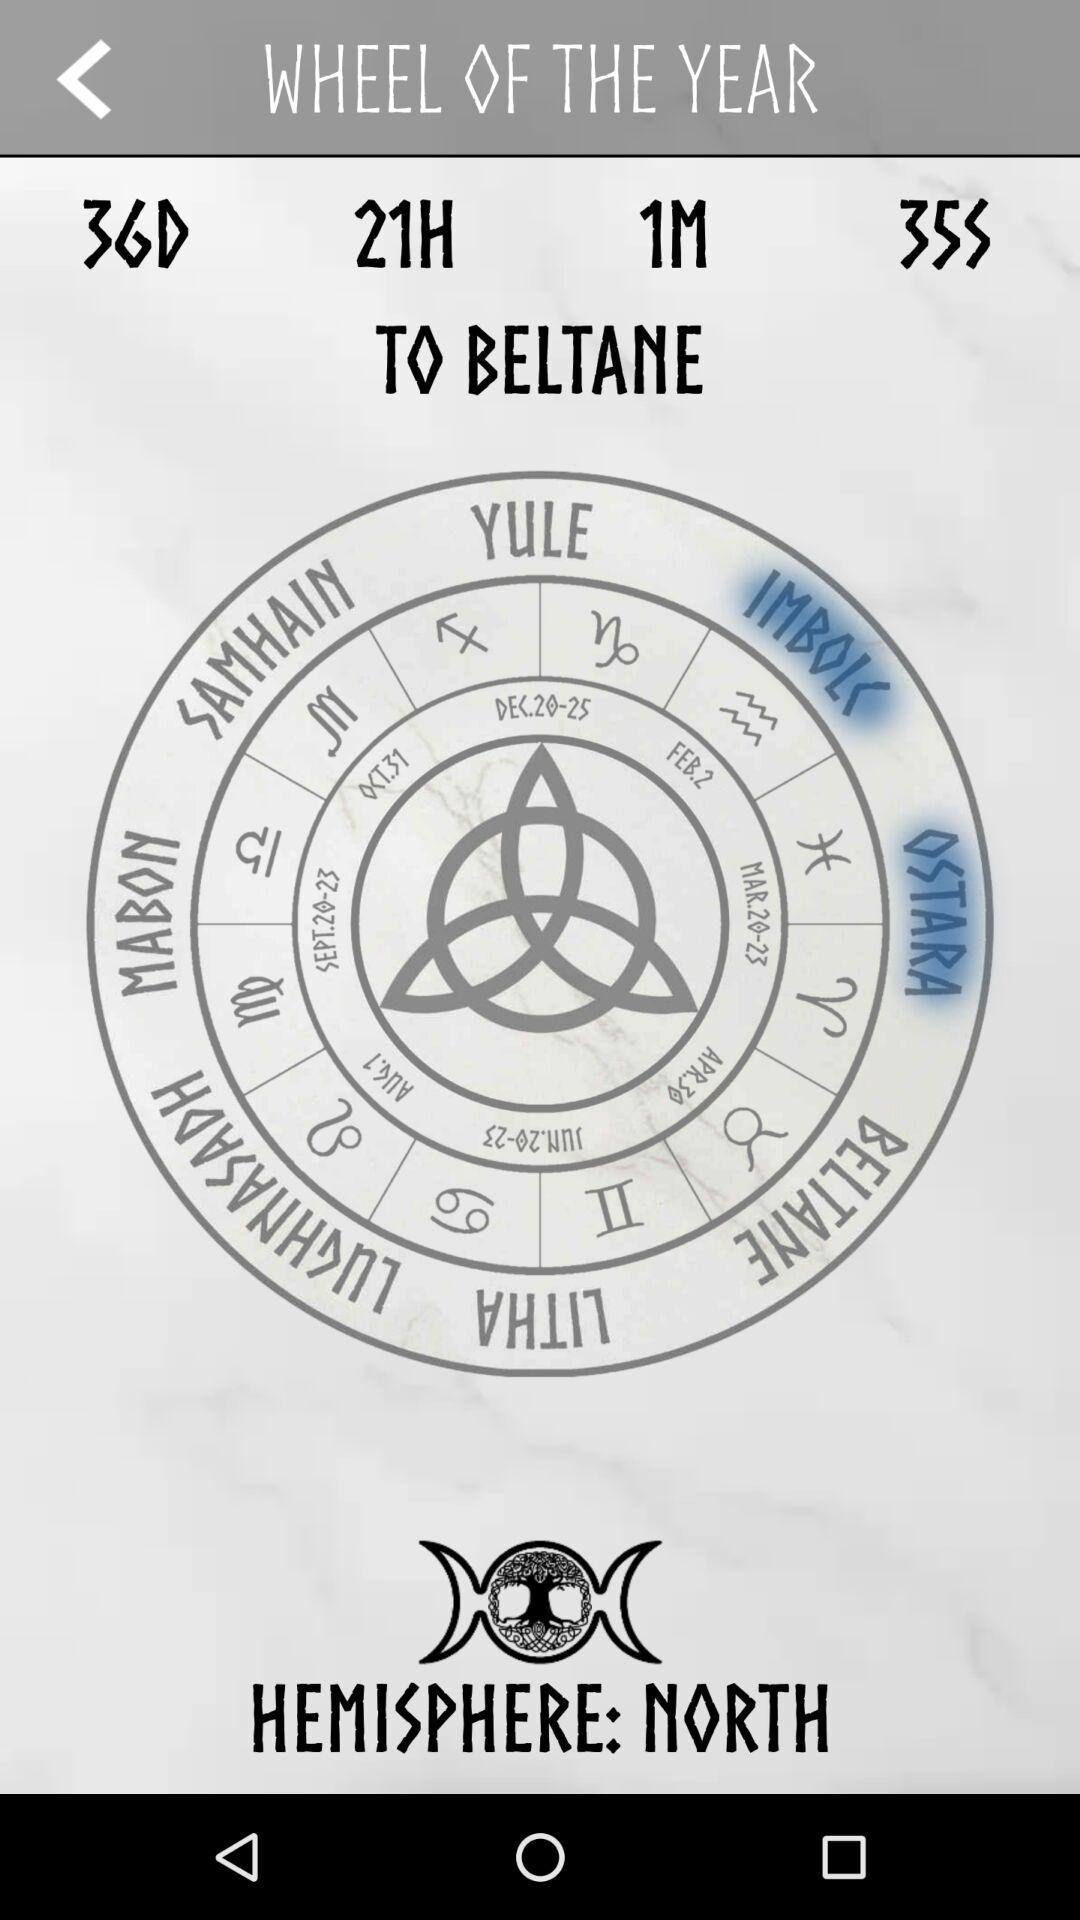How much time remains for the "BELTANE" to be held? The time remaining for the "BELTANE" to be held is 36 days 21 hours 1 minute 35 seconds. 